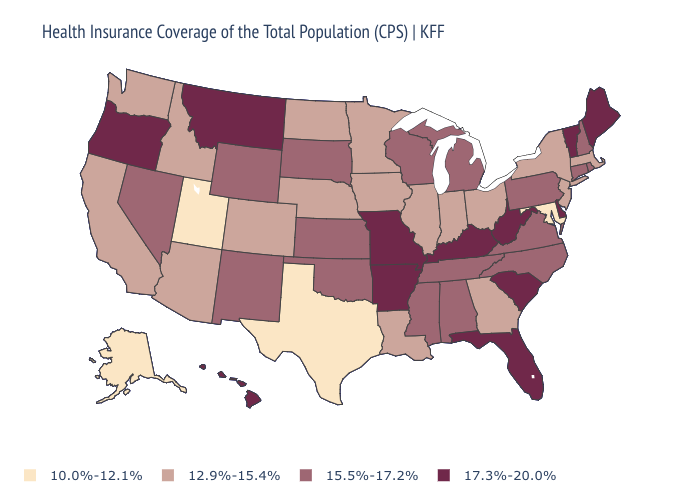Is the legend a continuous bar?
Write a very short answer. No. Which states hav the highest value in the South?
Short answer required. Arkansas, Delaware, Florida, Kentucky, South Carolina, West Virginia. Does Alaska have the lowest value in the USA?
Quick response, please. Yes. Which states have the lowest value in the USA?
Be succinct. Alaska, Maryland, Texas, Utah. Name the states that have a value in the range 17.3%-20.0%?
Keep it brief. Arkansas, Delaware, Florida, Hawaii, Kentucky, Maine, Missouri, Montana, Oregon, South Carolina, Vermont, West Virginia. How many symbols are there in the legend?
Short answer required. 4. Which states have the highest value in the USA?
Concise answer only. Arkansas, Delaware, Florida, Hawaii, Kentucky, Maine, Missouri, Montana, Oregon, South Carolina, Vermont, West Virginia. Name the states that have a value in the range 12.9%-15.4%?
Quick response, please. Arizona, California, Colorado, Georgia, Idaho, Illinois, Indiana, Iowa, Louisiana, Massachusetts, Minnesota, Nebraska, New Jersey, New York, North Dakota, Ohio, Washington. Does the first symbol in the legend represent the smallest category?
Short answer required. Yes. Name the states that have a value in the range 12.9%-15.4%?
Give a very brief answer. Arizona, California, Colorado, Georgia, Idaho, Illinois, Indiana, Iowa, Louisiana, Massachusetts, Minnesota, Nebraska, New Jersey, New York, North Dakota, Ohio, Washington. What is the value of Ohio?
Concise answer only. 12.9%-15.4%. What is the lowest value in states that border California?
Short answer required. 12.9%-15.4%. Name the states that have a value in the range 17.3%-20.0%?
Short answer required. Arkansas, Delaware, Florida, Hawaii, Kentucky, Maine, Missouri, Montana, Oregon, South Carolina, Vermont, West Virginia. What is the value of Missouri?
Be succinct. 17.3%-20.0%. What is the value of Iowa?
Keep it brief. 12.9%-15.4%. 